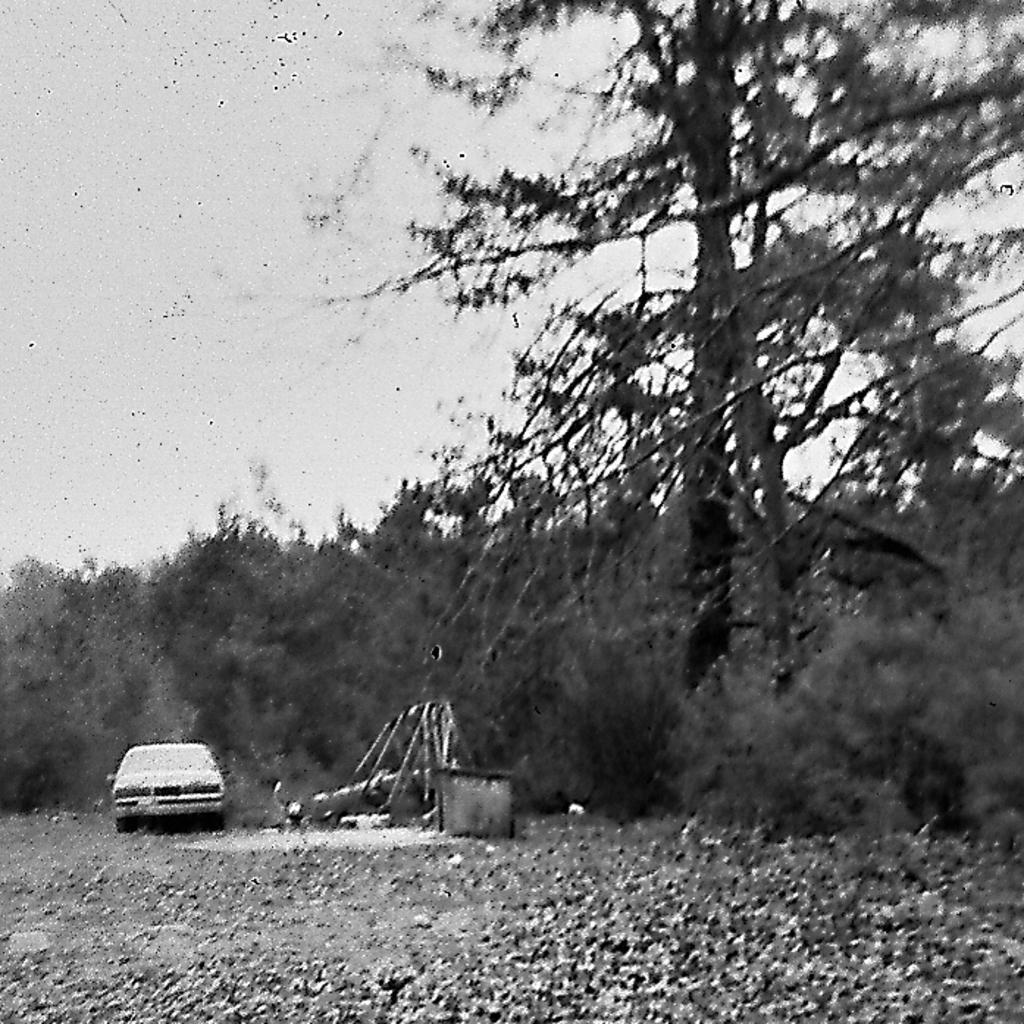Could you give a brief overview of what you see in this image? There are trees and a car in the middle of this image and the sky is in the background. 